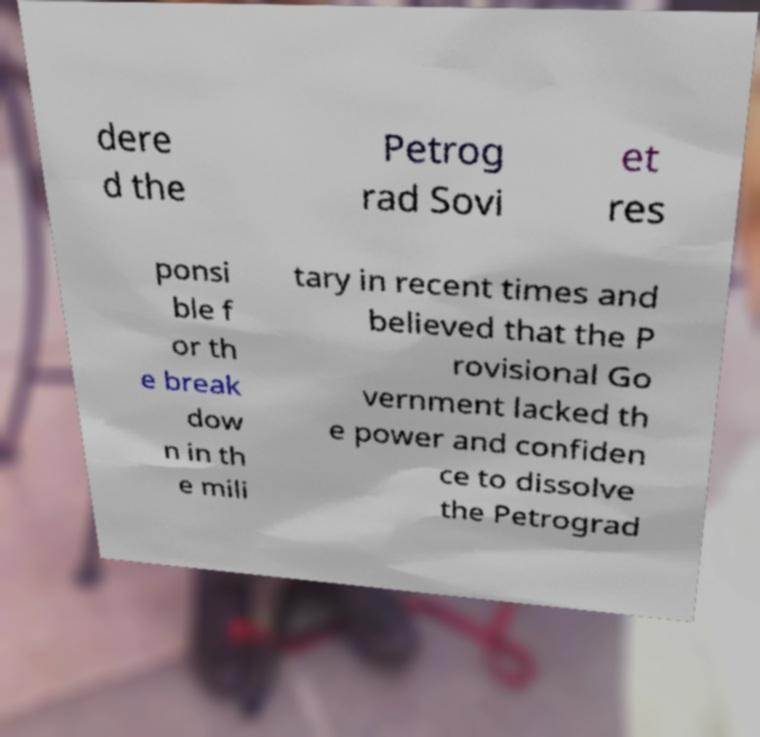Can you accurately transcribe the text from the provided image for me? dere d the Petrog rad Sovi et res ponsi ble f or th e break dow n in th e mili tary in recent times and believed that the P rovisional Go vernment lacked th e power and confiden ce to dissolve the Petrograd 